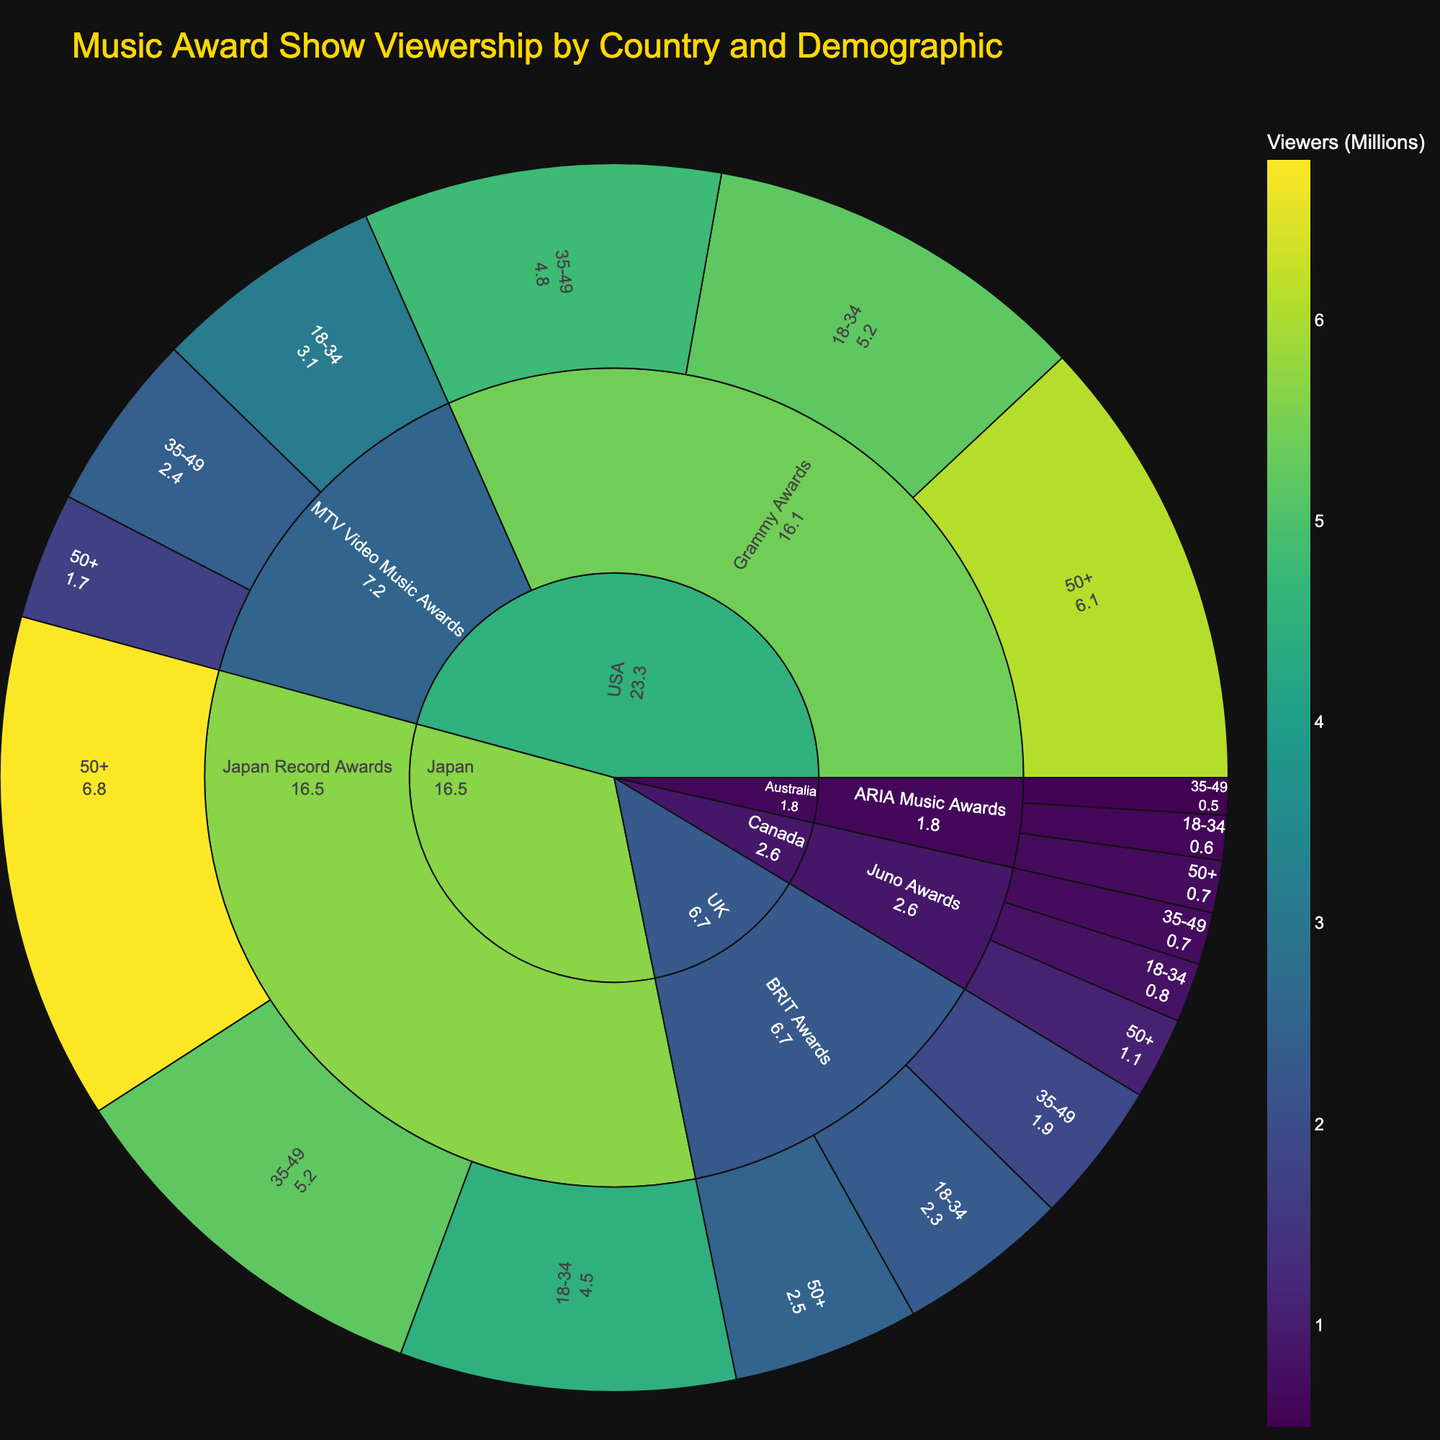What's the title of the plot? The title of the plot is prominently displayed at the top of the figure and gives the context for the visualization.
Answer: Music Award Show Viewership by Country and Demographic Which country has the highest viewership for a single award show? To find the country with the highest viewership, look at the largest segment in the plot. The color intensity and segment size indicate the number of viewers.
Answer: USA What is the total viewership for the Grammy Awards in the USA across all demographics? Locate the segments for the USA and Grammy Awards, and add the viewership numbers for each demographic: 5.2 (18-34), 4.8 (35-49), and 6.1 (50+). The sum is 5.2 + 4.8 + 6.1.
Answer: 16.1 million Which demographic in Japan has the highest viewership for the Japan Record Awards? Find the Japan segment, then look for the Japan Record Awards sub-segment and compare the viewership for 18-34, 35-49, and 50+ demographics.
Answer: 50+ How does the viewership for the 18-34 demographic for the BRIT Awards in the UK compare to the 18-34 demographic for the MTV Video Music Awards in the USA? Identify the segments for the 18-34 demographic in both UK (BRIT Awards) and USA (MTV Video Music Awards). Compare their viewership: 2.3 (UK) vs. 3.1 (USA).
Answer: Higher in the USA Which award show has the least viewers among the 50+ demographic in Australia? Look for the segments under Australia, 50+ demographic and compare the viewership numbers for the ARIA Music Awards. There is just one award show segment.
Answer: ARIA Music Awards What is the combined viewership for the 35-49 demographic across all countries and award shows? Sum the viewership numbers for the 35-49 demographic in all countries and all award shows: 4.8 (USA, Grammy) + 2.4 (USA, MTV) + 1.9 (UK, BRIT) + 0.7 (Canada, Juno) + 0.5 (Australia, ARIA) + 5.2 (Japan, Record). Total: 4.8 + 2.4 + 1.9 + 0.7 + 0.5 + 5.2.
Answer: 15.5 million In which country does the viewership for the 18-34 demographic exceed the viewership for the 35-49 demographic for the same award show? Compare the 18-34 and 35-49 segments within each country's sub-segment for each award show. The viewership for the 18-34 demographic exceeds the 35-49 demographic in USA (Grammy, MTV), UK (BRIT), and Japan (Record).
Answer: USA, UK, Japan Which demographic has the highest viewership for the Juno Awards in Canada? For the Canada segment, unlock the sub-segment for the Juno Awards and compare the demographics' viewership: 0.8 (18-34), 0.7 (35-49), 1.1 (50+).
Answer: 50+ Explain the distribution of viewership for the ARIA Music Awards in Australia across demographics. Analyze the sub-segment for Australia and ARIA Music Awards: the viewership numbers are 0.6 (18-34), 0.5 (35-49), and 0.7 (50+). The distribution shows that the 50+ demographic has the most viewers, while 35-49 has the least.
Answer: Highest in 50+, Lowest in 35-49 